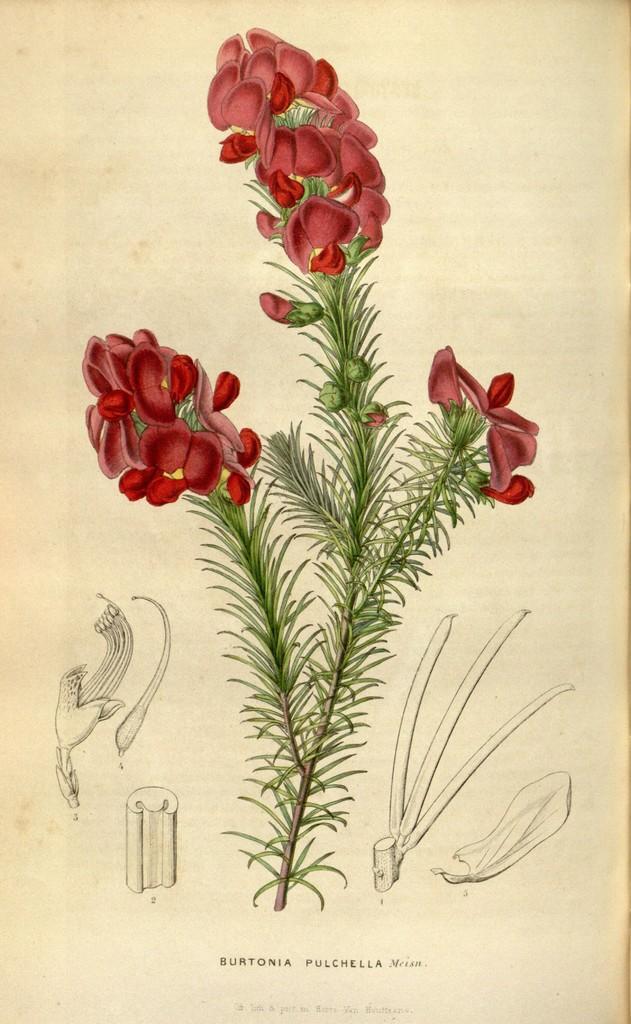In one or two sentences, can you explain what this image depicts? In this image I can see the painting of a plant. 